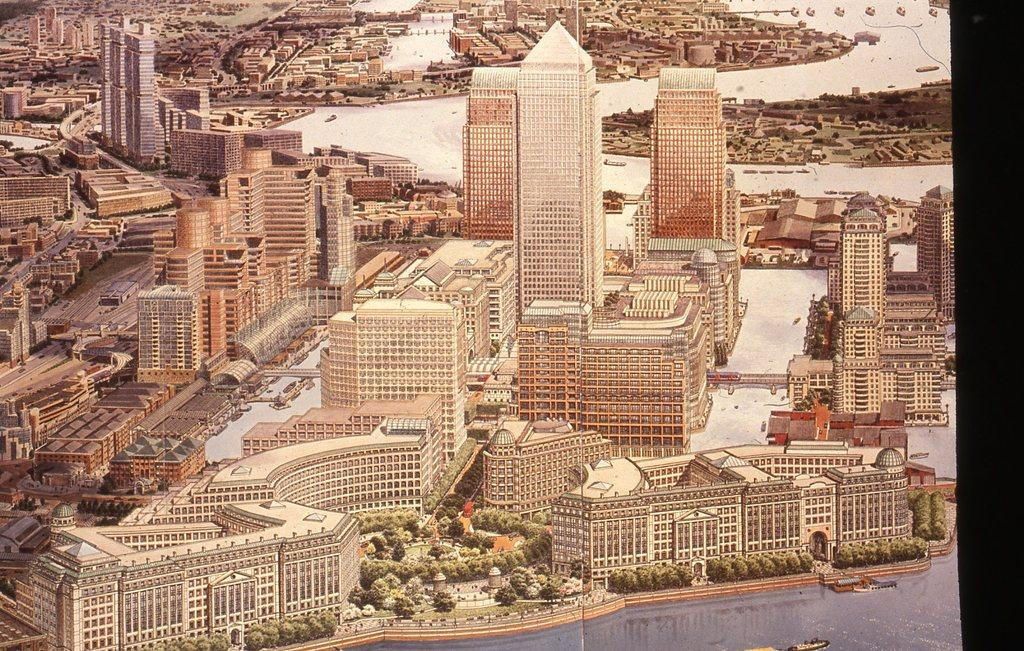What type of structures can be seen in the image? There are many buildings in the image. What other natural elements are present in the image? There are trees in the image. Can you describe the water feature in the image? There is a boat in the water in the image. What type of shoe can be seen on the boat in the image? There is no shoe present on the boat in the image. What type of flight is taking place in the image? There is no flight present in the image; it features buildings, trees, and a boat in the water. 